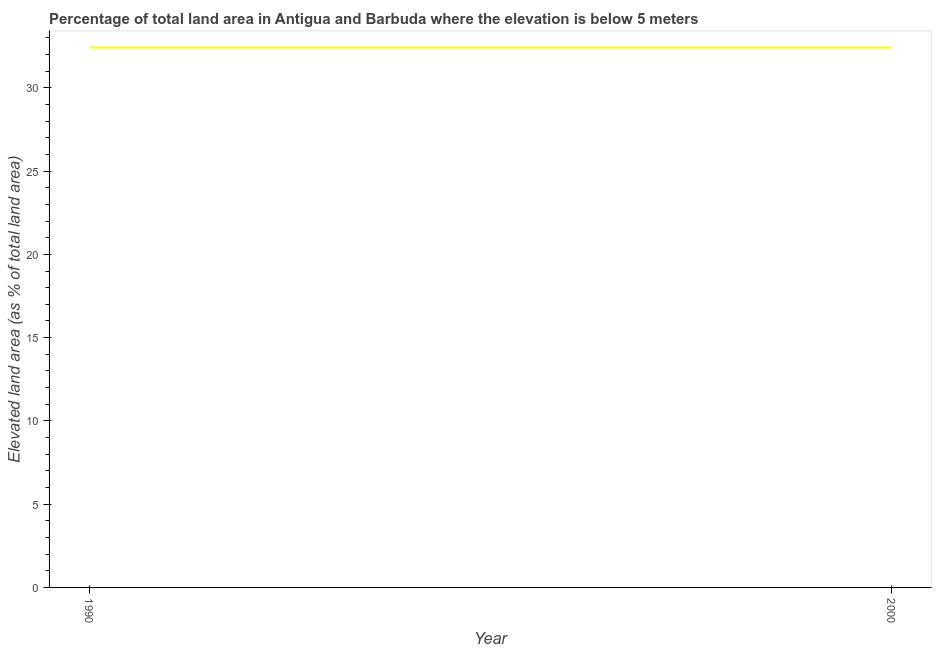What is the total elevated land area in 1990?
Give a very brief answer. 32.42. Across all years, what is the maximum total elevated land area?
Offer a terse response. 32.42. Across all years, what is the minimum total elevated land area?
Provide a short and direct response. 32.42. In which year was the total elevated land area minimum?
Your response must be concise. 1990. What is the sum of the total elevated land area?
Your answer should be very brief. 64.85. What is the average total elevated land area per year?
Make the answer very short. 32.42. What is the median total elevated land area?
Ensure brevity in your answer.  32.42. What is the difference between two consecutive major ticks on the Y-axis?
Offer a terse response. 5. Are the values on the major ticks of Y-axis written in scientific E-notation?
Your response must be concise. No. What is the title of the graph?
Give a very brief answer. Percentage of total land area in Antigua and Barbuda where the elevation is below 5 meters. What is the label or title of the X-axis?
Provide a short and direct response. Year. What is the label or title of the Y-axis?
Ensure brevity in your answer.  Elevated land area (as % of total land area). What is the Elevated land area (as % of total land area) of 1990?
Provide a short and direct response. 32.42. What is the Elevated land area (as % of total land area) of 2000?
Give a very brief answer. 32.42. What is the difference between the Elevated land area (as % of total land area) in 1990 and 2000?
Your answer should be very brief. 0. What is the ratio of the Elevated land area (as % of total land area) in 1990 to that in 2000?
Your answer should be compact. 1. 